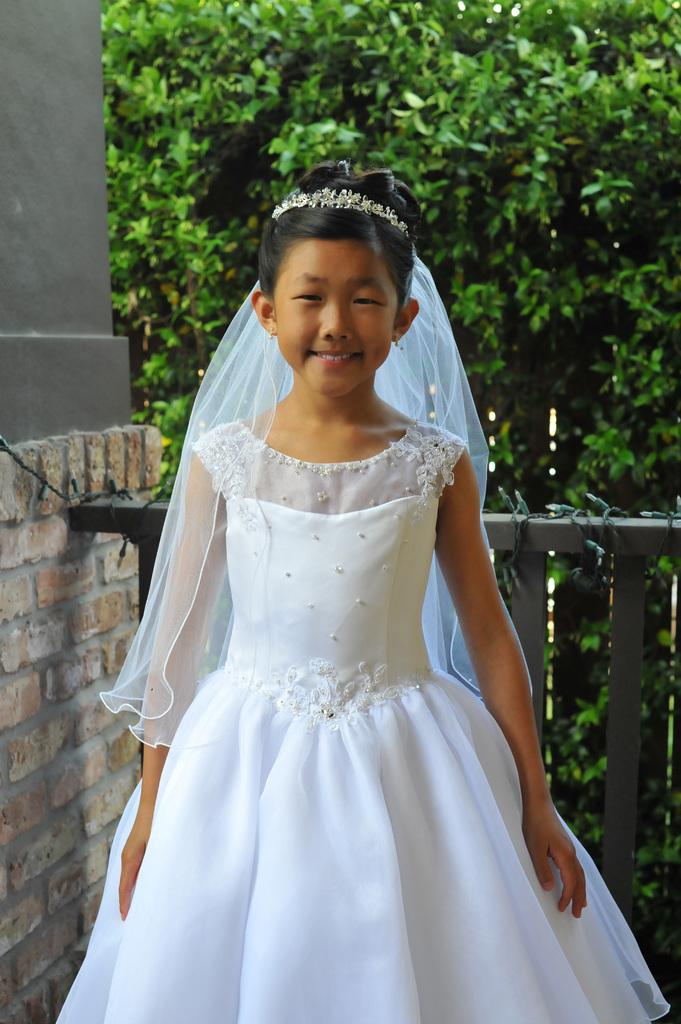What is the main subject of the image? There is a kid in the image. What is the kid's expression in the image? The kid is smiling. What can be seen in the background of the image? There is a tree in the background of the image. What type of structure is on the left side of the image? There is a brick wall on the left side of the image. What type of architectural feature is visible in the image? There is railing visible in the image. What type of coat is hanging from the tree in the image? There is no coat hanging from the tree in the image; only a kid, a tree, a brick wall, and railing are present. What type of bells can be heard ringing in the image? There are no bells present in the image, and therefore no sound can be heard. 